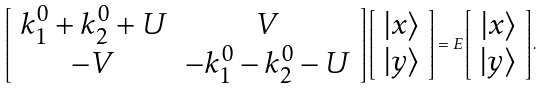<formula> <loc_0><loc_0><loc_500><loc_500>\left [ \begin{array} { c c } k _ { 1 } ^ { 0 } + k _ { 2 } ^ { 0 } + U & V \\ - V & - k _ { 1 } ^ { 0 } - k _ { 2 } ^ { 0 } - U \end{array} \right ] \left [ \begin{array} { c } | x \rangle \\ | y \rangle \end{array} \right ] = E \left [ \begin{array} { c } | x \rangle \\ | y \rangle \end{array} \right ] .</formula> 